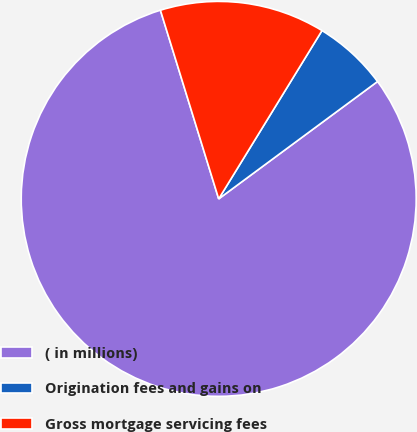Convert chart to OTSL. <chart><loc_0><loc_0><loc_500><loc_500><pie_chart><fcel>( in millions)<fcel>Origination fees and gains on<fcel>Gross mortgage servicing fees<nl><fcel>80.36%<fcel>6.11%<fcel>13.53%<nl></chart> 